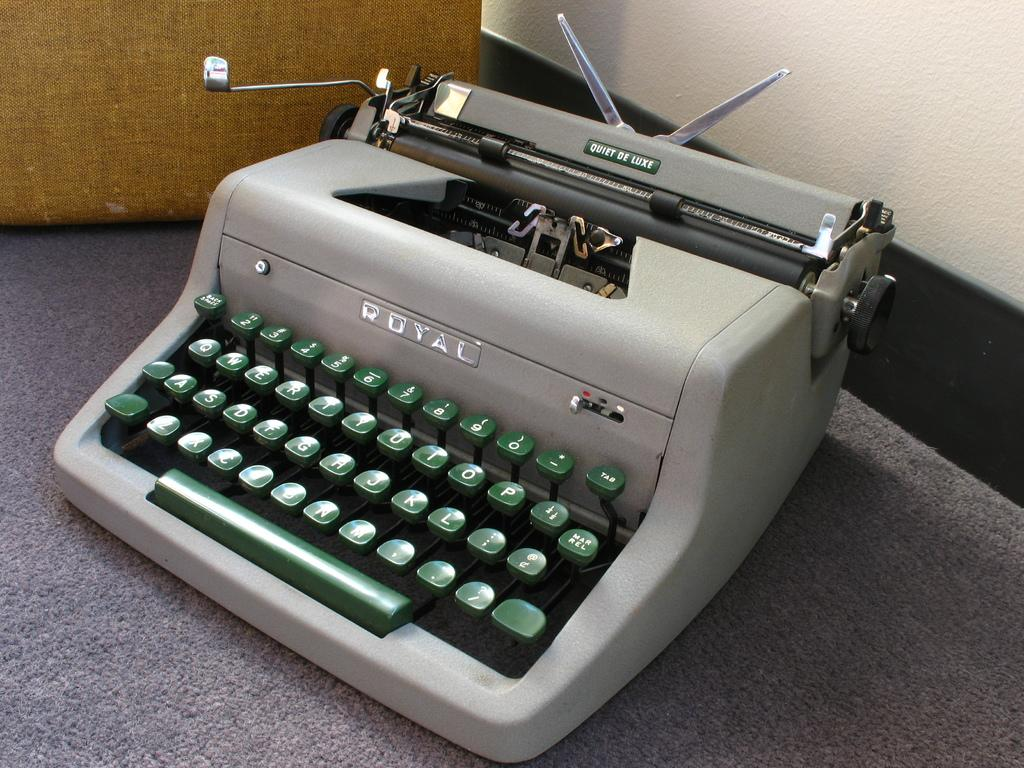What is the main object in the image? There is a typing machine in the image. Can you describe the color of the typing machine? The typing machine is ash colored. What can be seen in the background of the image? There is a wall in the background of the image. What is the color of the wall? The wall is white colored. How many leaves are on the typing machine in the image? There are no leaves present on the typing machine in the image. 